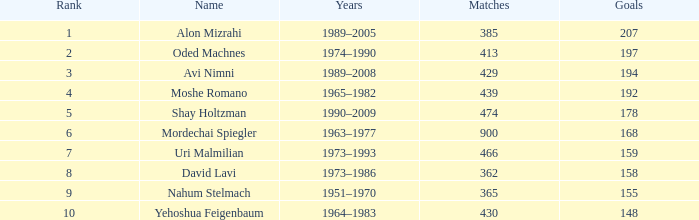What is the Rank of the player with 158 Goals in more than 362 Matches? 0.0. 